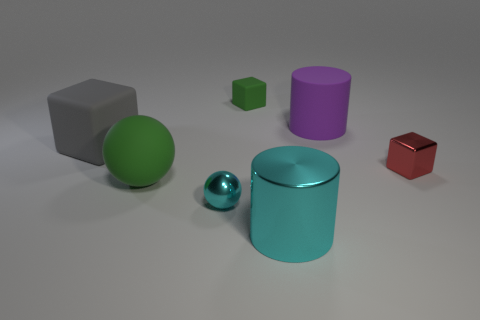What size is the gray cube?
Give a very brief answer. Large. Do the cyan metallic cylinder and the matte block left of the small cyan ball have the same size?
Give a very brief answer. Yes. The small ball in front of the shiny thing behind the matte thing in front of the large gray rubber cube is what color?
Your answer should be very brief. Cyan. Is the material of the small thing behind the big purple cylinder the same as the big purple cylinder?
Your response must be concise. Yes. What number of other things are made of the same material as the big green object?
Give a very brief answer. 3. What material is the gray block that is the same size as the green matte ball?
Your answer should be compact. Rubber. Do the cyan shiny object that is behind the big cyan cylinder and the green object in front of the tiny matte cube have the same shape?
Make the answer very short. Yes. What shape is the red shiny thing that is the same size as the green block?
Offer a very short reply. Cube. Is the material of the tiny object that is to the right of the purple matte cylinder the same as the cylinder behind the metal cylinder?
Offer a terse response. No. There is a green thing that is in front of the large gray block; are there any red objects to the left of it?
Provide a succinct answer. No. 